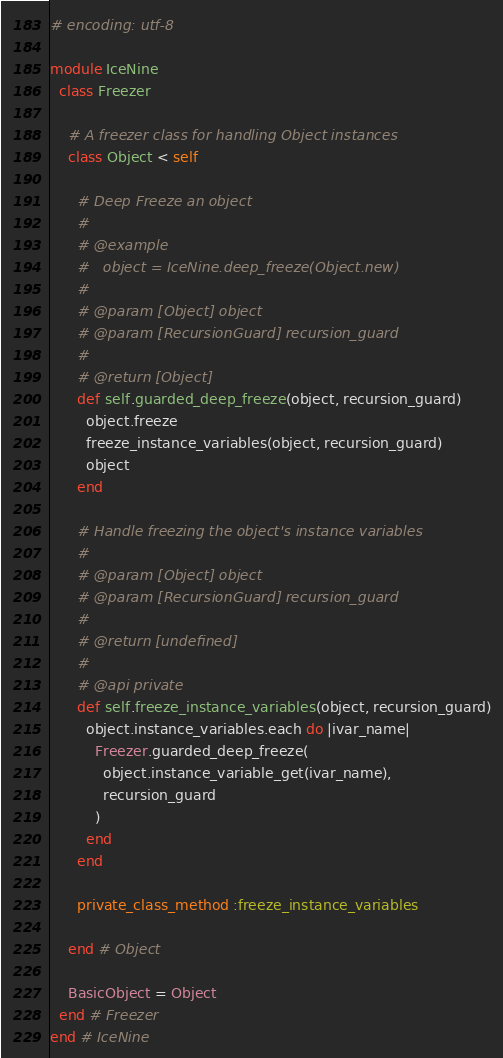Convert code to text. <code><loc_0><loc_0><loc_500><loc_500><_Ruby_># encoding: utf-8

module IceNine
  class Freezer

    # A freezer class for handling Object instances
    class Object < self

      # Deep Freeze an object
      #
      # @example
      #   object = IceNine.deep_freeze(Object.new)
      #
      # @param [Object] object
      # @param [RecursionGuard] recursion_guard
      #
      # @return [Object]
      def self.guarded_deep_freeze(object, recursion_guard)
        object.freeze
        freeze_instance_variables(object, recursion_guard)
        object
      end

      # Handle freezing the object's instance variables
      #
      # @param [Object] object
      # @param [RecursionGuard] recursion_guard
      #
      # @return [undefined]
      #
      # @api private
      def self.freeze_instance_variables(object, recursion_guard)
        object.instance_variables.each do |ivar_name|
          Freezer.guarded_deep_freeze(
            object.instance_variable_get(ivar_name),
            recursion_guard
          )
        end
      end

      private_class_method :freeze_instance_variables

    end # Object

    BasicObject = Object
  end # Freezer
end # IceNine
</code> 